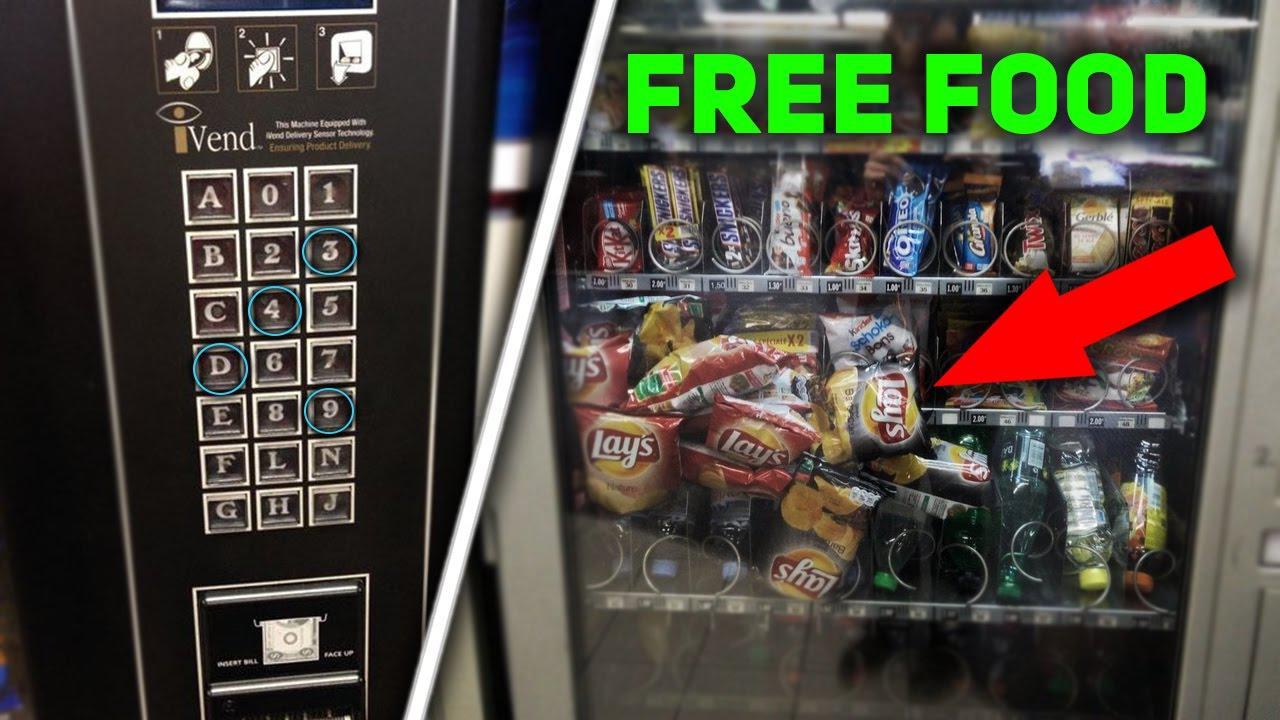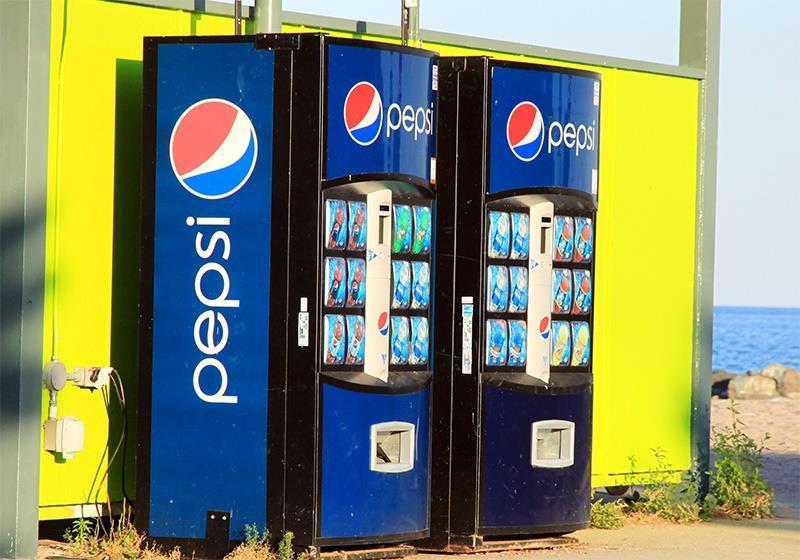The first image is the image on the left, the second image is the image on the right. Assess this claim about the two images: "The machine on the right sells Coca Cola.". Correct or not? Answer yes or no. No. 